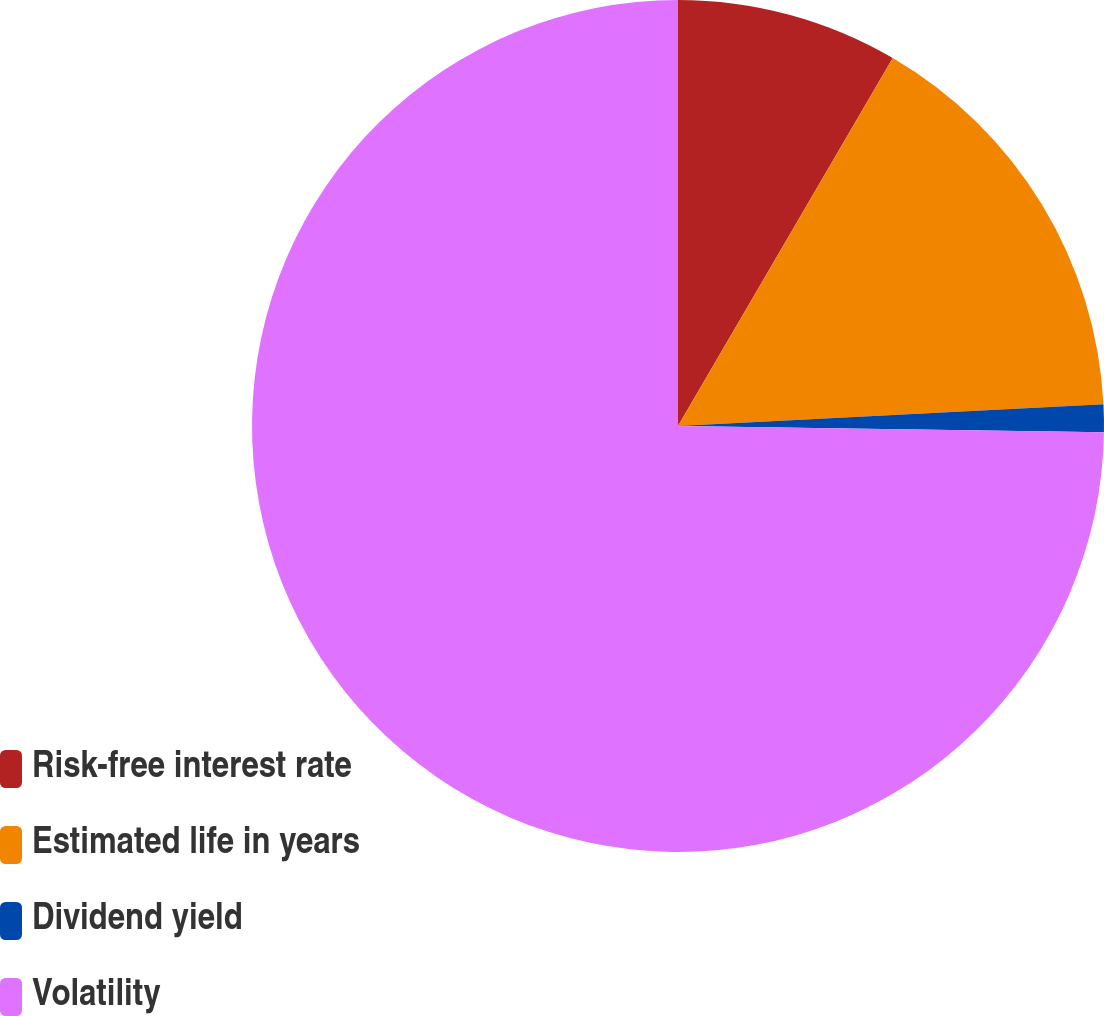<chart> <loc_0><loc_0><loc_500><loc_500><pie_chart><fcel>Risk-free interest rate<fcel>Estimated life in years<fcel>Dividend yield<fcel>Volatility<nl><fcel>8.41%<fcel>15.78%<fcel>1.04%<fcel>74.77%<nl></chart> 